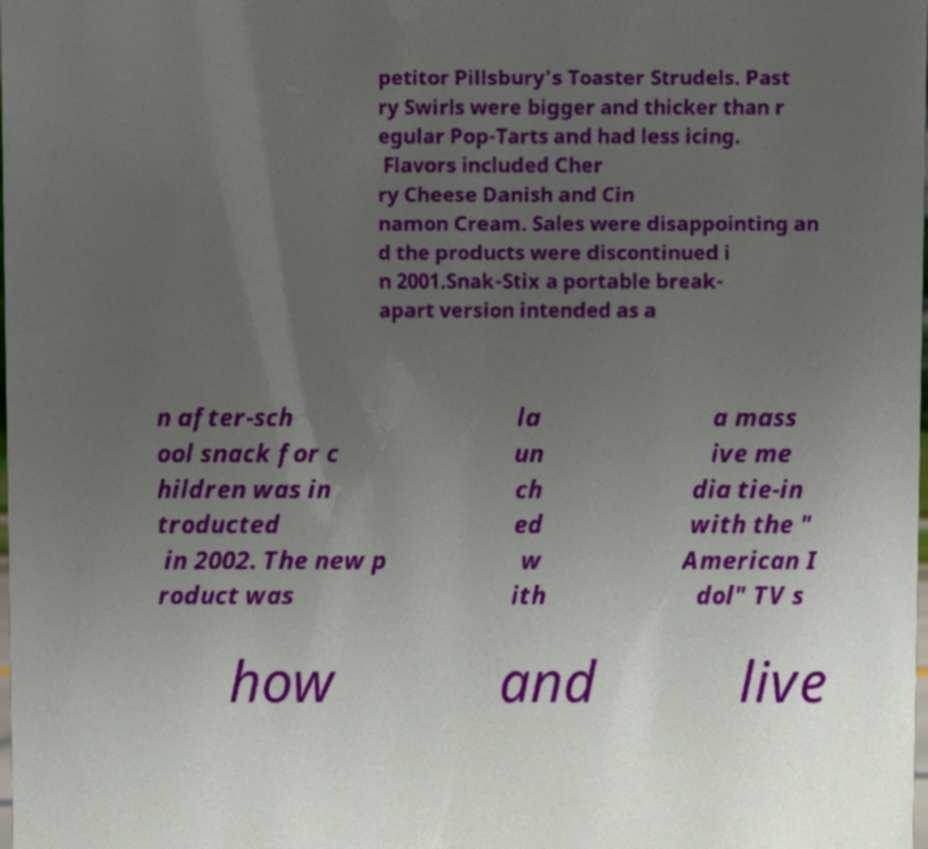What messages or text are displayed in this image? I need them in a readable, typed format. petitor Pillsbury's Toaster Strudels. Past ry Swirls were bigger and thicker than r egular Pop-Tarts and had less icing. Flavors included Cher ry Cheese Danish and Cin namon Cream. Sales were disappointing an d the products were discontinued i n 2001.Snak-Stix a portable break- apart version intended as a n after-sch ool snack for c hildren was in troducted in 2002. The new p roduct was la un ch ed w ith a mass ive me dia tie-in with the " American I dol" TV s how and live 